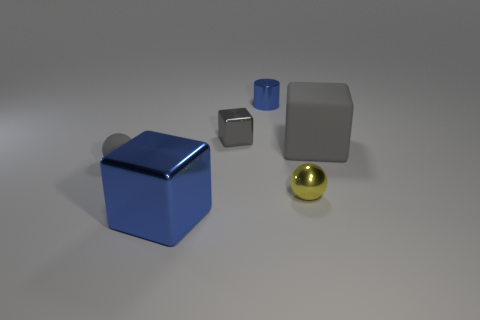Subtract all gray blocks. How many blocks are left? 1 Add 2 tiny metallic cylinders. How many objects exist? 8 Subtract all gray blocks. How many blocks are left? 1 Subtract 2 spheres. How many spheres are left? 0 Subtract all purple blocks. Subtract all gray spheres. How many blocks are left? 3 Subtract all gray cubes. How many yellow spheres are left? 1 Subtract all small blue balls. Subtract all small blue shiny objects. How many objects are left? 5 Add 1 blue objects. How many blue objects are left? 3 Add 4 big gray matte things. How many big gray matte things exist? 5 Subtract 1 blue cylinders. How many objects are left? 5 